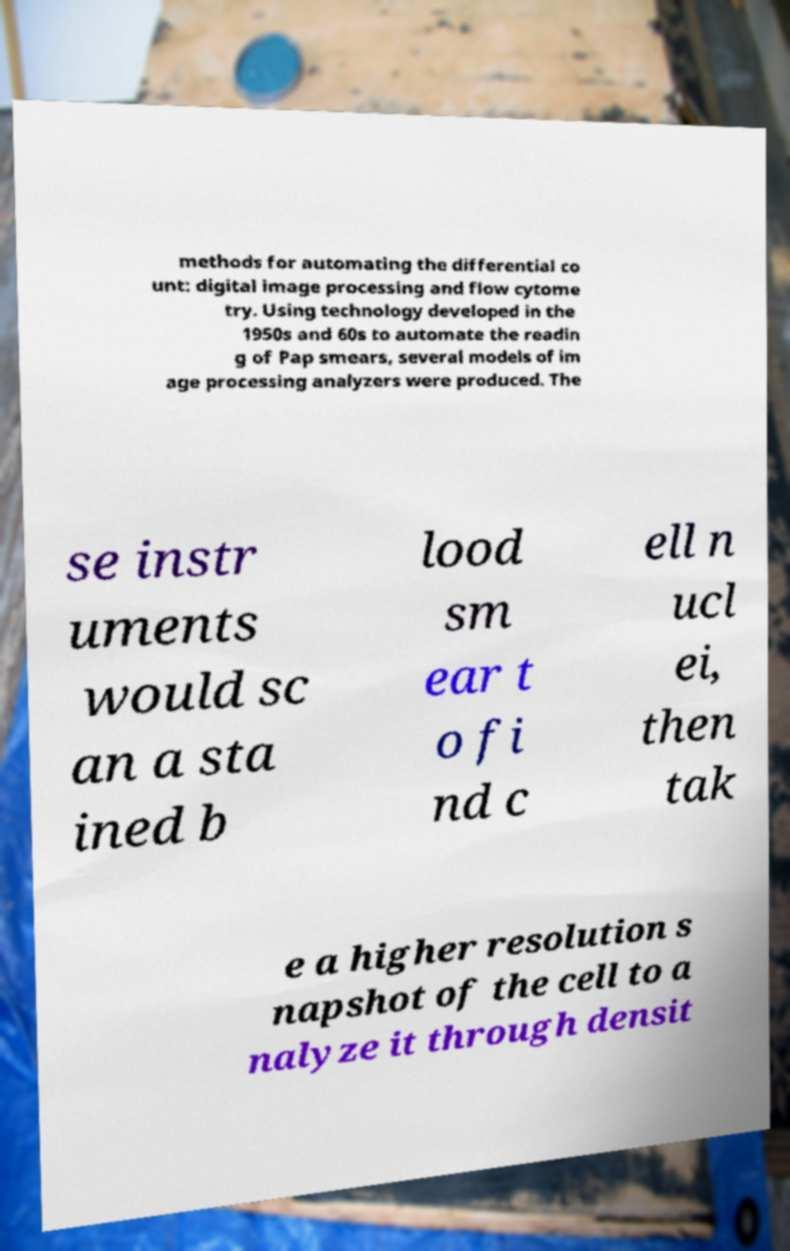Can you accurately transcribe the text from the provided image for me? methods for automating the differential co unt: digital image processing and flow cytome try. Using technology developed in the 1950s and 60s to automate the readin g of Pap smears, several models of im age processing analyzers were produced. The se instr uments would sc an a sta ined b lood sm ear t o fi nd c ell n ucl ei, then tak e a higher resolution s napshot of the cell to a nalyze it through densit 